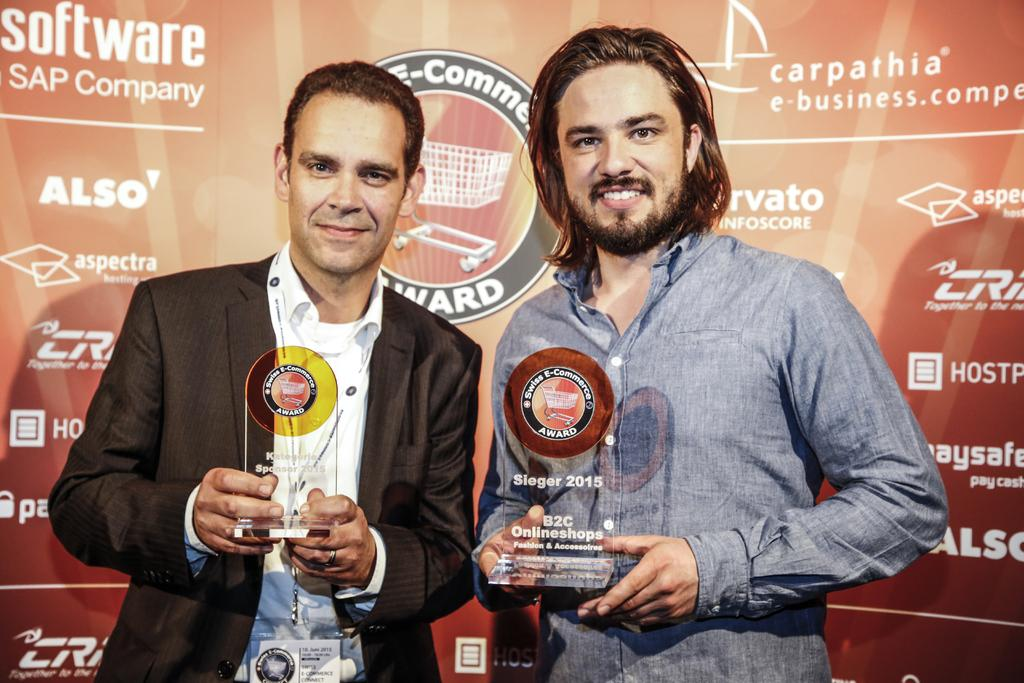How many people are in the image? There are two people in the image. What are the people holding in the image? The people are holding trophies. What can be seen in the background of the image? There is a banner in the background of the image. What type of representative is standing next to the crook in the image? There is no representative or crook present in the image. How many passengers are visible in the image? There are no passengers visible in the image; it features two people holding trophies. 